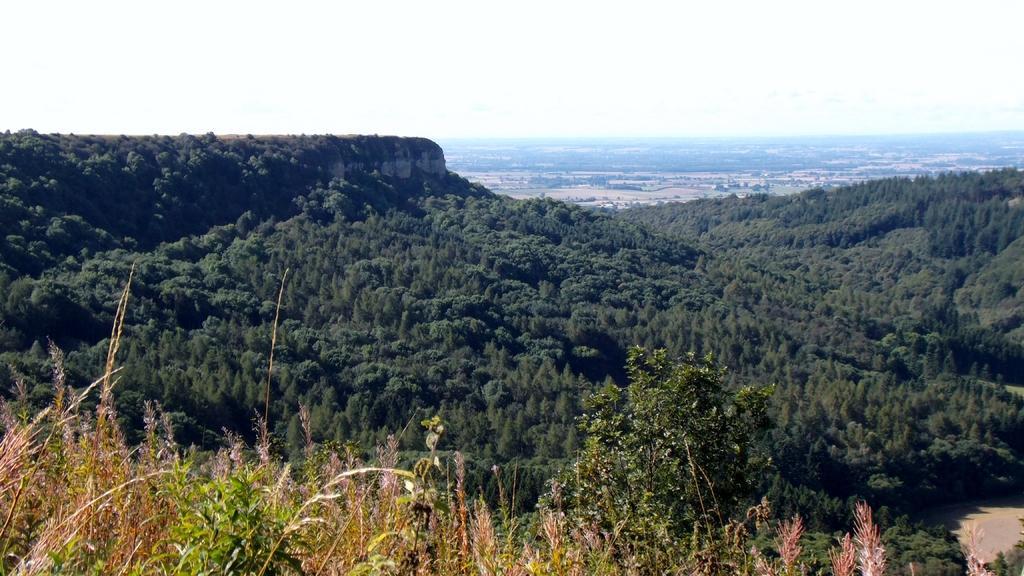In one or two sentences, can you explain what this image depicts? This image is taken outdoors. At the bottom of the image there are many trees and plants on the hill. 